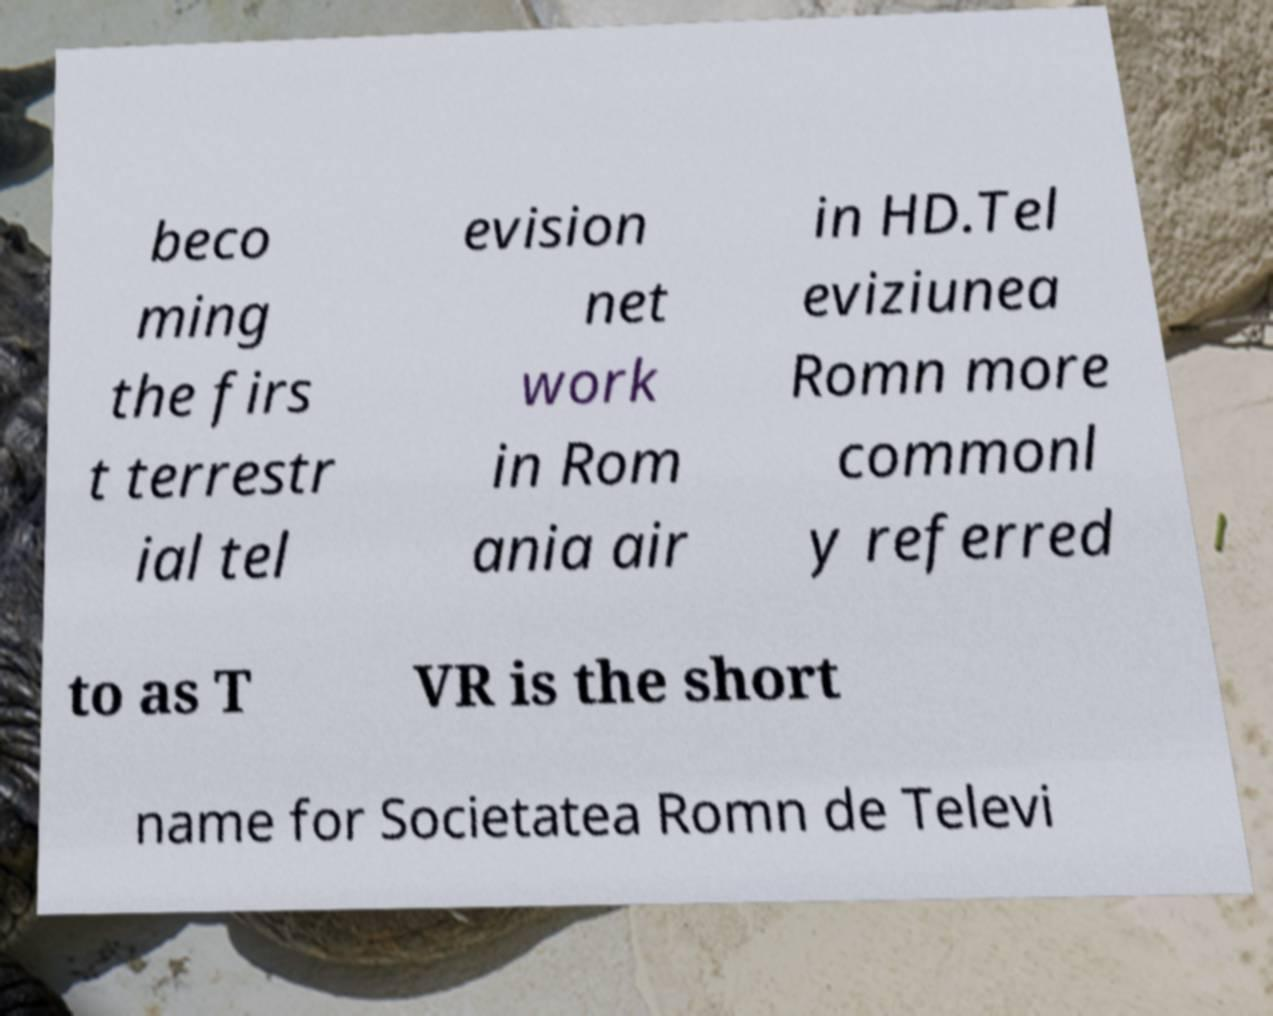Could you assist in decoding the text presented in this image and type it out clearly? beco ming the firs t terrestr ial tel evision net work in Rom ania air in HD.Tel eviziunea Romn more commonl y referred to as T VR is the short name for Societatea Romn de Televi 